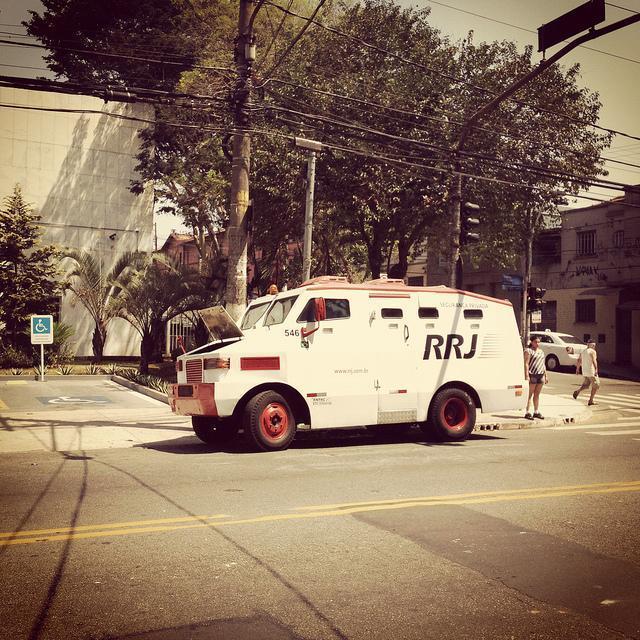How many trucks can be seen?
Give a very brief answer. 1. 